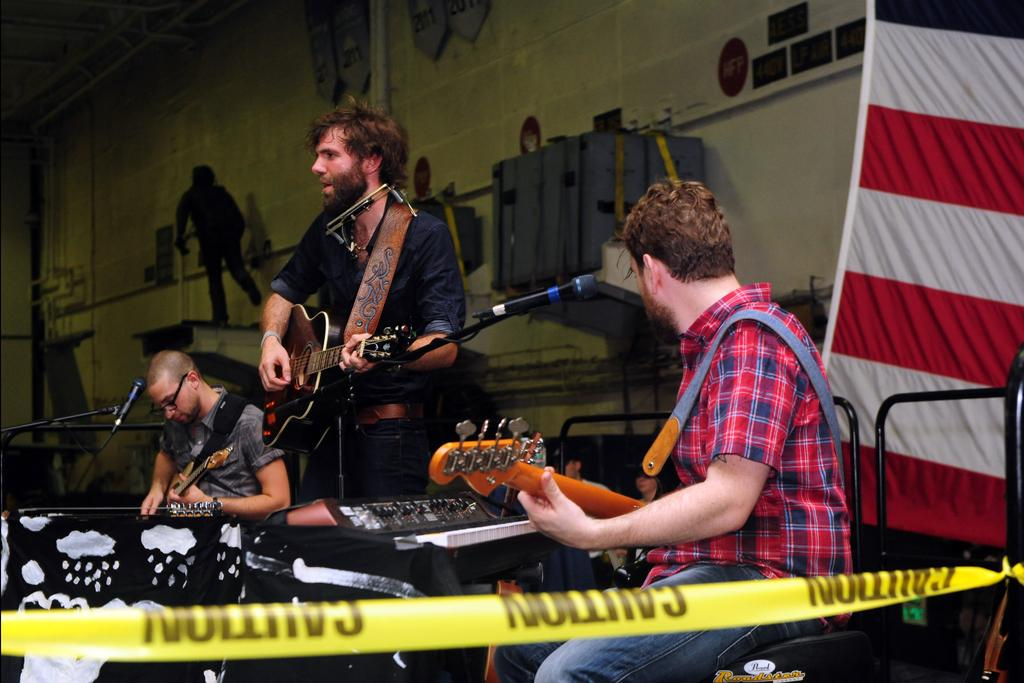How many people are in the image? There are three persons in the image. What are the persons doing in the image? Each person is playing a guitar. What object is present in front of the persons? There is a microphone in front of the persons. What type of pan can be seen being used by the persons in the image? There is no pan present in the image; the persons are playing guitars and standing near a microphone. 